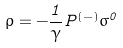Convert formula to latex. <formula><loc_0><loc_0><loc_500><loc_500>\rho = - \frac { 1 } { \gamma } P ^ { ( - ) } \sigma ^ { 0 }</formula> 